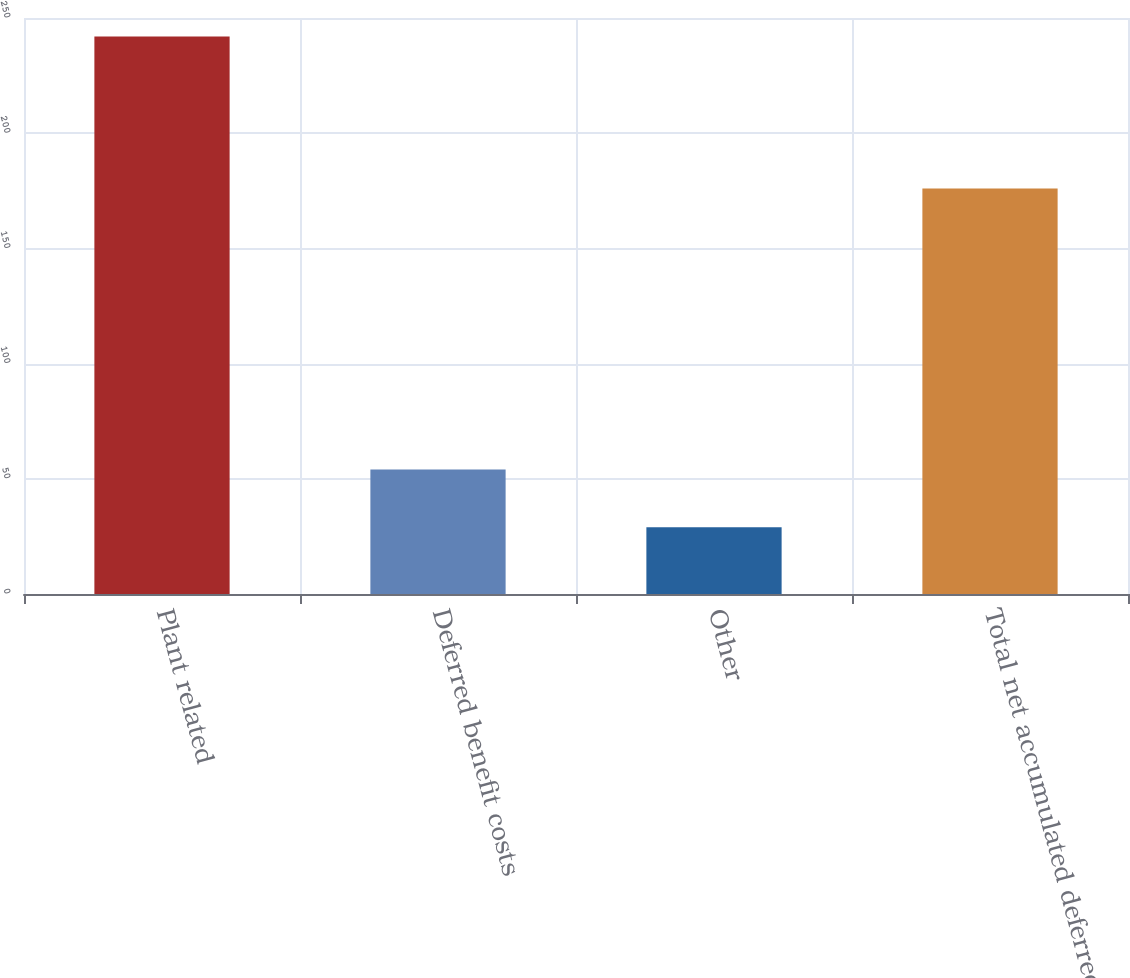<chart> <loc_0><loc_0><loc_500><loc_500><bar_chart><fcel>Plant related<fcel>Deferred benefit costs<fcel>Other<fcel>Total net accumulated deferred<nl><fcel>242<fcel>54<fcel>29<fcel>176<nl></chart> 